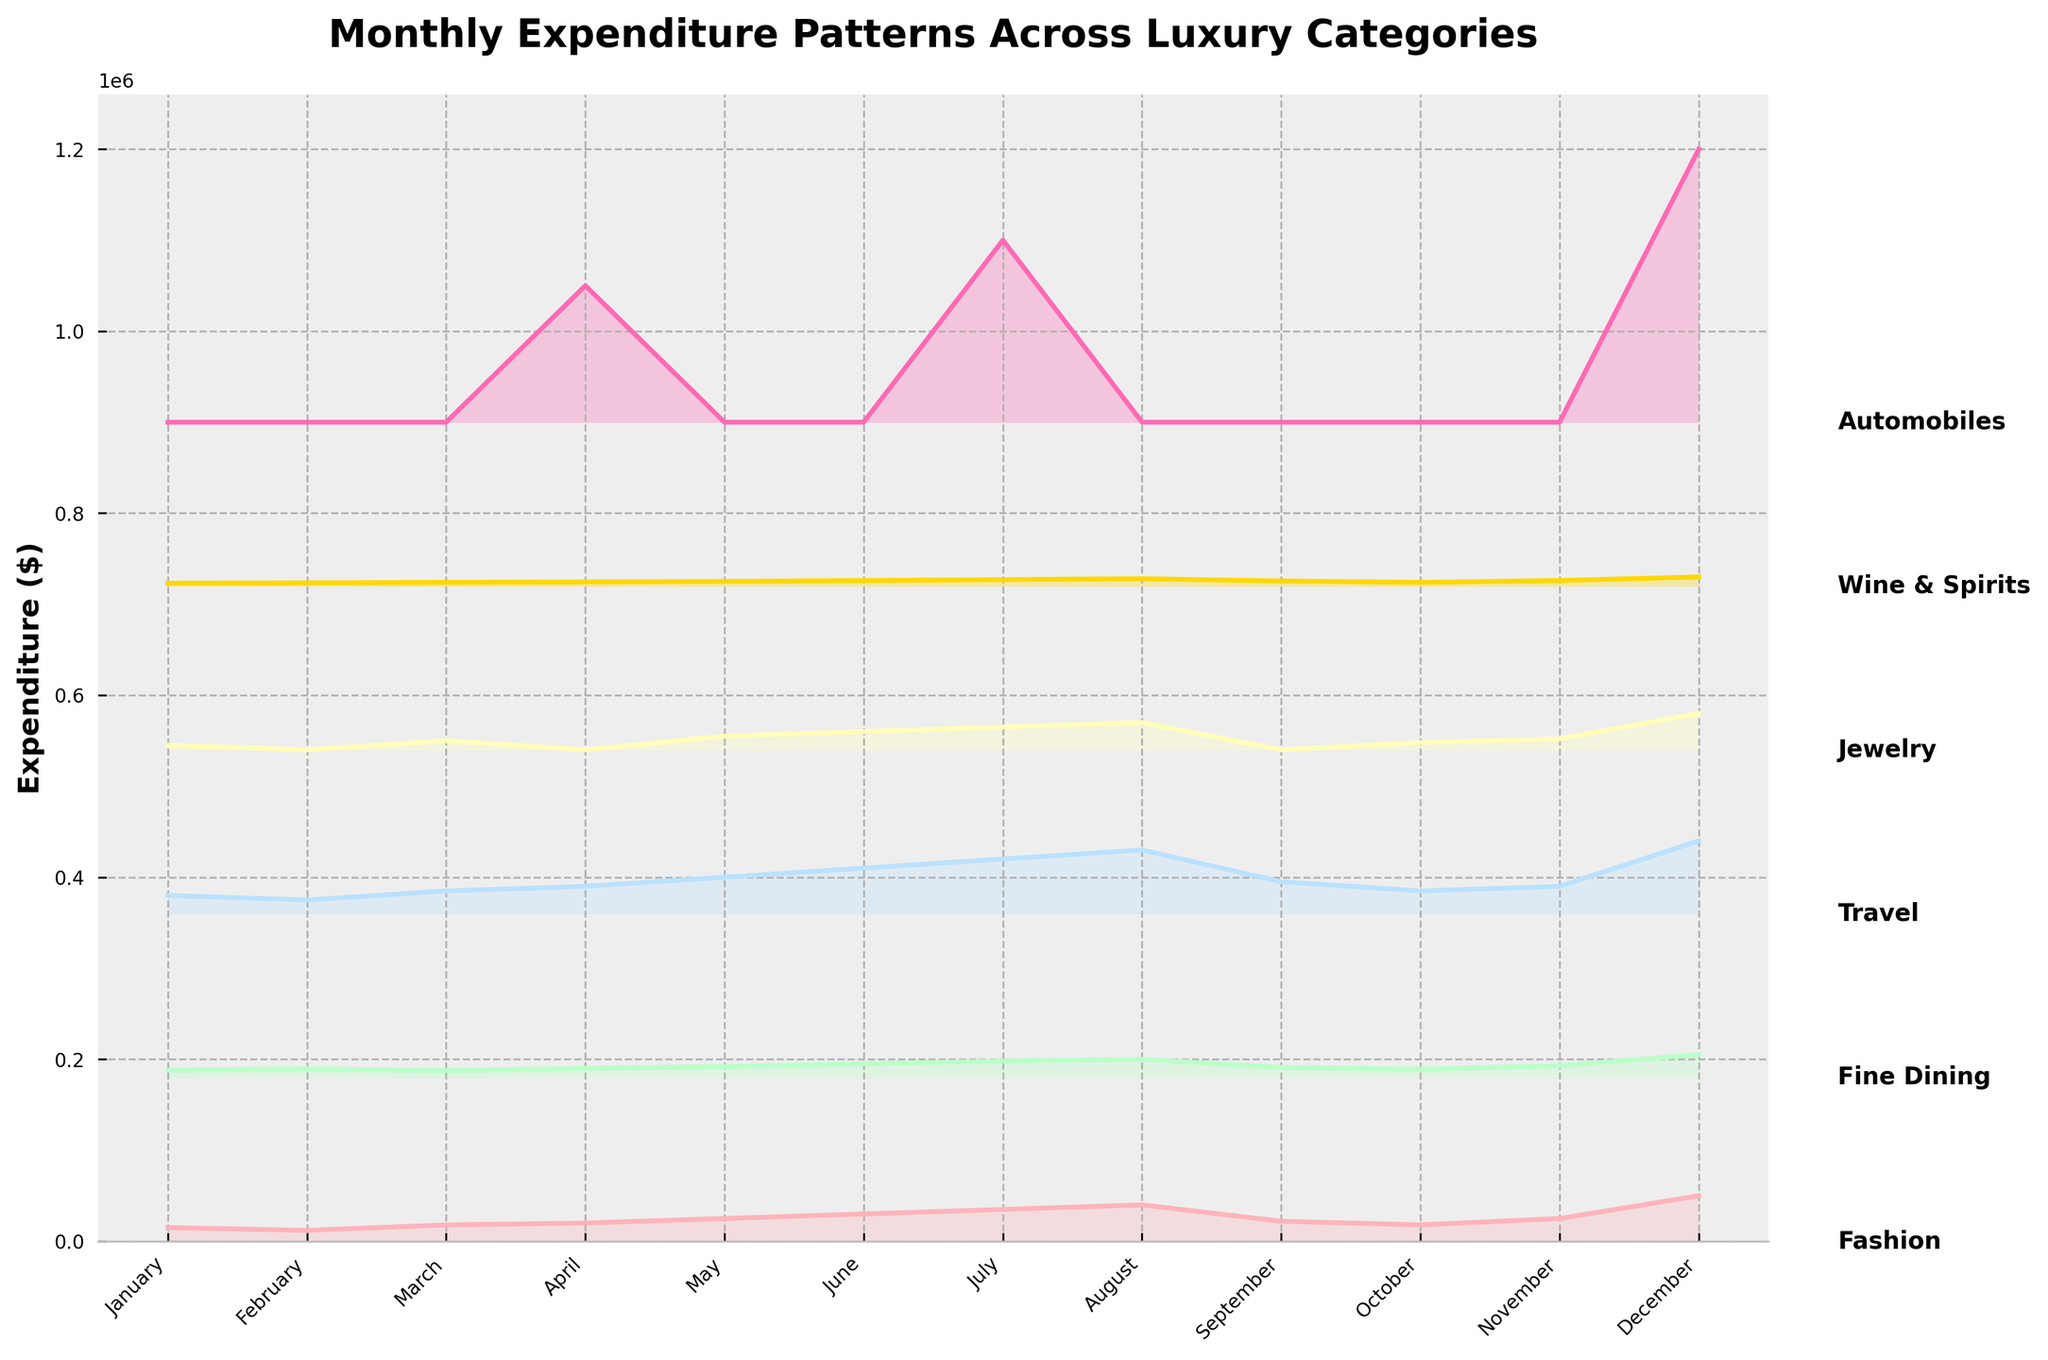What is the title of the plot? The title can be found at the top of the plot. It reads "Monthly Expenditure Patterns Across Luxury Categories".
Answer: Monthly Expenditure Patterns Across Luxury Categories How are the months labeled on the x-axis? By looking at the x-axis, we see that months are labeled with their names from "January" to "December".
Answer: January to December Which category has the highest expenditure in December? Observing the ridgeline plot, we notice that "Automobiles" has the highest expenditure in December as its line peaks the highest.
Answer: Automobiles During which month is there no expenditure on Jewelry? Referring to the Jewelry category line, we see that it drops to the baseline in February and September, indicating no expenditure in those months.
Answer: February and September What is the trend in Fashion expenditures over the year? Checking the Fashion expenditure line, the trend shows an overall increase from January through December, with some fluctuations along the way.
Answer: Overall increasing Which month shows the highest overall expenditure across all categories? By comparing the combined height of all ridgelines, December shows the highest overall expenditure, notably due to high spending in both Automobiles and Fashion categories.
Answer: December What is the total expenditure on Fine Dining in the first quarter (January, February, March)? Adding the values for Fine Dining in January (8000), February (9500), and March (7500), we get 8000 + 9500 + 7500 = 25000.
Answer: 25000 Between which two months is there the greatest increase in expenditure for Travel? Observing the Travel expenditure line, the greatest increase occurs between November (30000) and December (80000), a jump of 50000.
Answer: November to December How does expenditure on Wine & Spirits in July compare to January? Comparing the Wine & Spirits expenditure line for January (3000) and July (7000), we see that it is more than double in July.
Answer: More than double Is there any month with zero expenditure on Automobiles? If yes, which are they? Checking the Automobiles expenditure line, there are zeros in January, February, March, May, June, August, September, October, and November.
Answer: January, February, March, May, June, August, September, October, November 